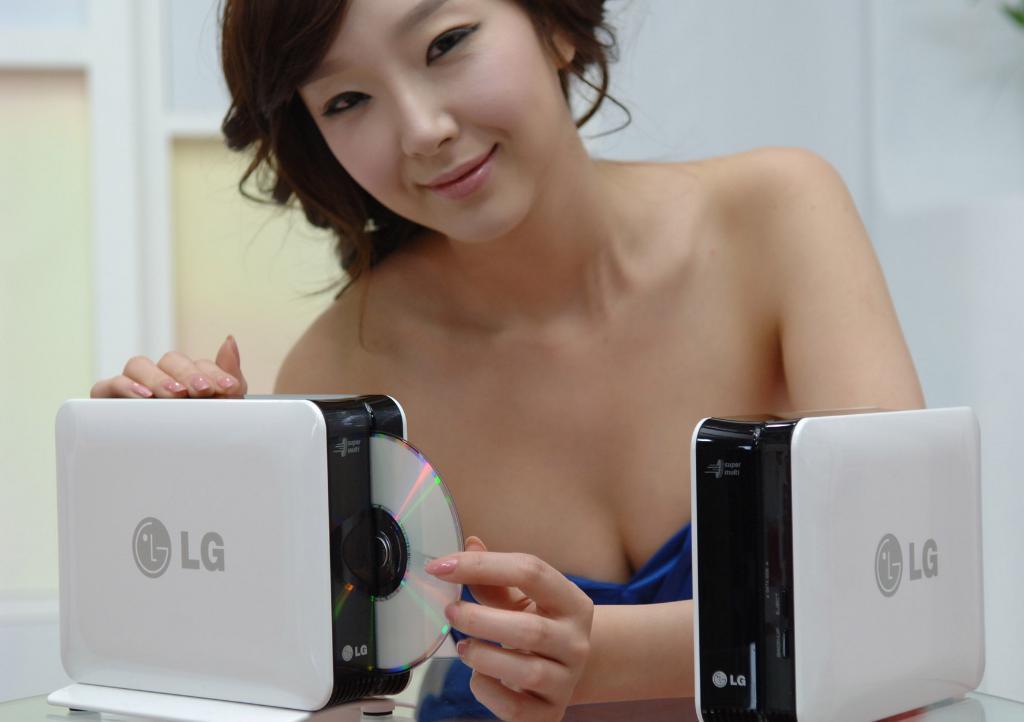Please provide a concise description of this image. This image is taken indoors. In the background there is a wall with a door. At the bottom of the image there is a table with two devices on it. In the middle of the image a woman is standing and she is with a smiling face. She is holding a CD and a device in her hands. 